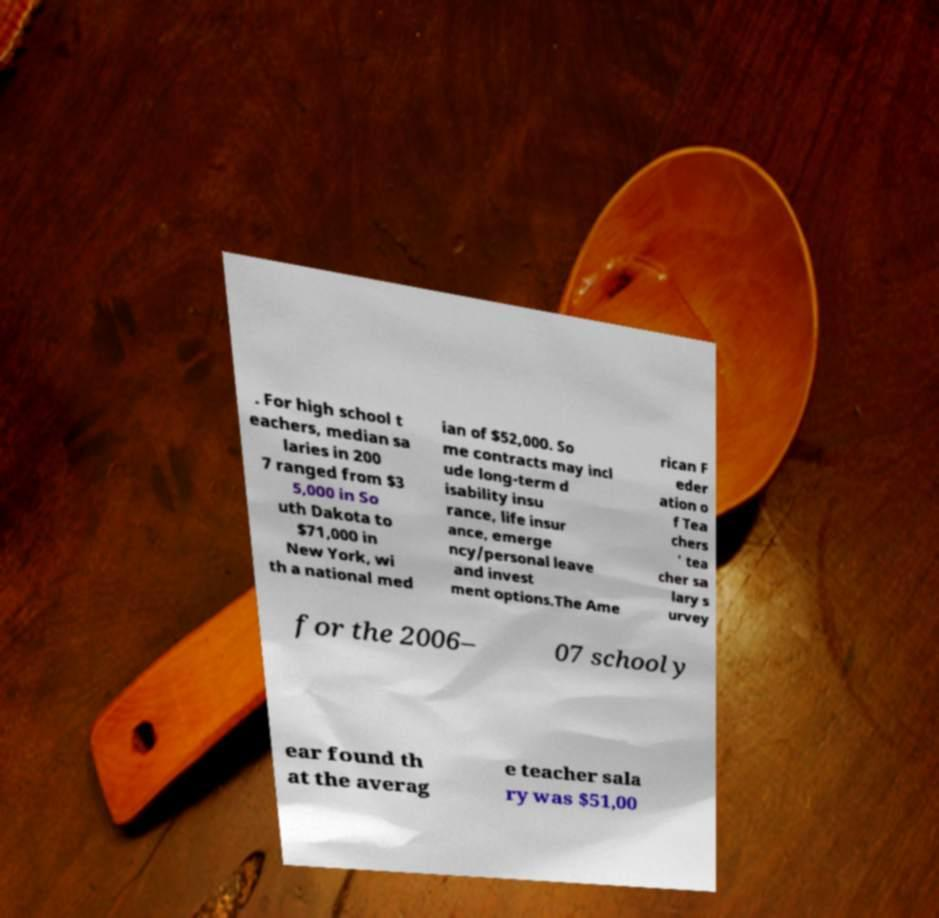There's text embedded in this image that I need extracted. Can you transcribe it verbatim? . For high school t eachers, median sa laries in 200 7 ranged from $3 5,000 in So uth Dakota to $71,000 in New York, wi th a national med ian of $52,000. So me contracts may incl ude long-term d isability insu rance, life insur ance, emerge ncy/personal leave and invest ment options.The Ame rican F eder ation o f Tea chers ' tea cher sa lary s urvey for the 2006– 07 school y ear found th at the averag e teacher sala ry was $51,00 